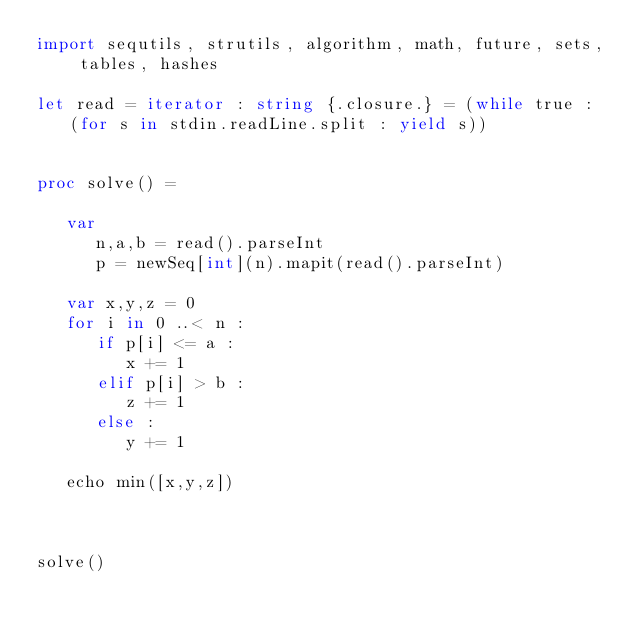<code> <loc_0><loc_0><loc_500><loc_500><_Nim_>import sequtils, strutils, algorithm, math, future, sets, tables, hashes

let read = iterator : string {.closure.} = (while true : (for s in stdin.readLine.split : yield s))


proc solve() =
   
   var
      n,a,b = read().parseInt
      p = newSeq[int](n).mapit(read().parseInt)

   var x,y,z = 0
   for i in 0 ..< n : 
      if p[i] <= a : 
         x += 1
      elif p[i] > b : 
         z += 1
      else : 
         y += 1

   echo min([x,y,z])
      
   

solve()</code> 